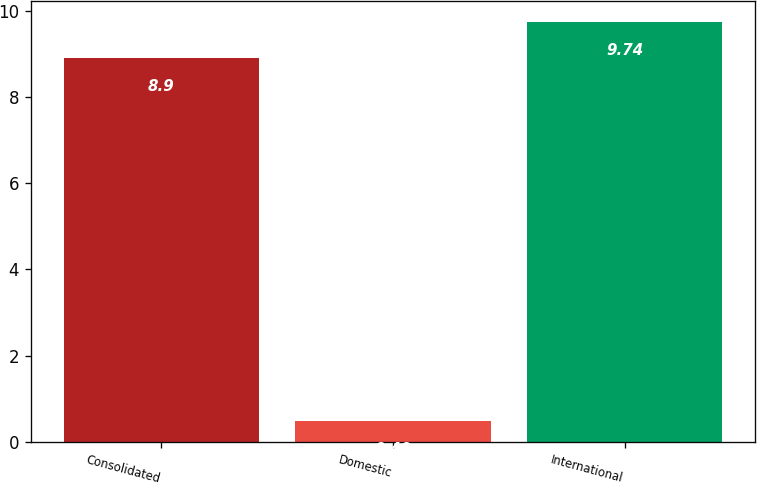Convert chart to OTSL. <chart><loc_0><loc_0><loc_500><loc_500><bar_chart><fcel>Consolidated<fcel>Domestic<fcel>International<nl><fcel>8.9<fcel>0.49<fcel>9.74<nl></chart> 